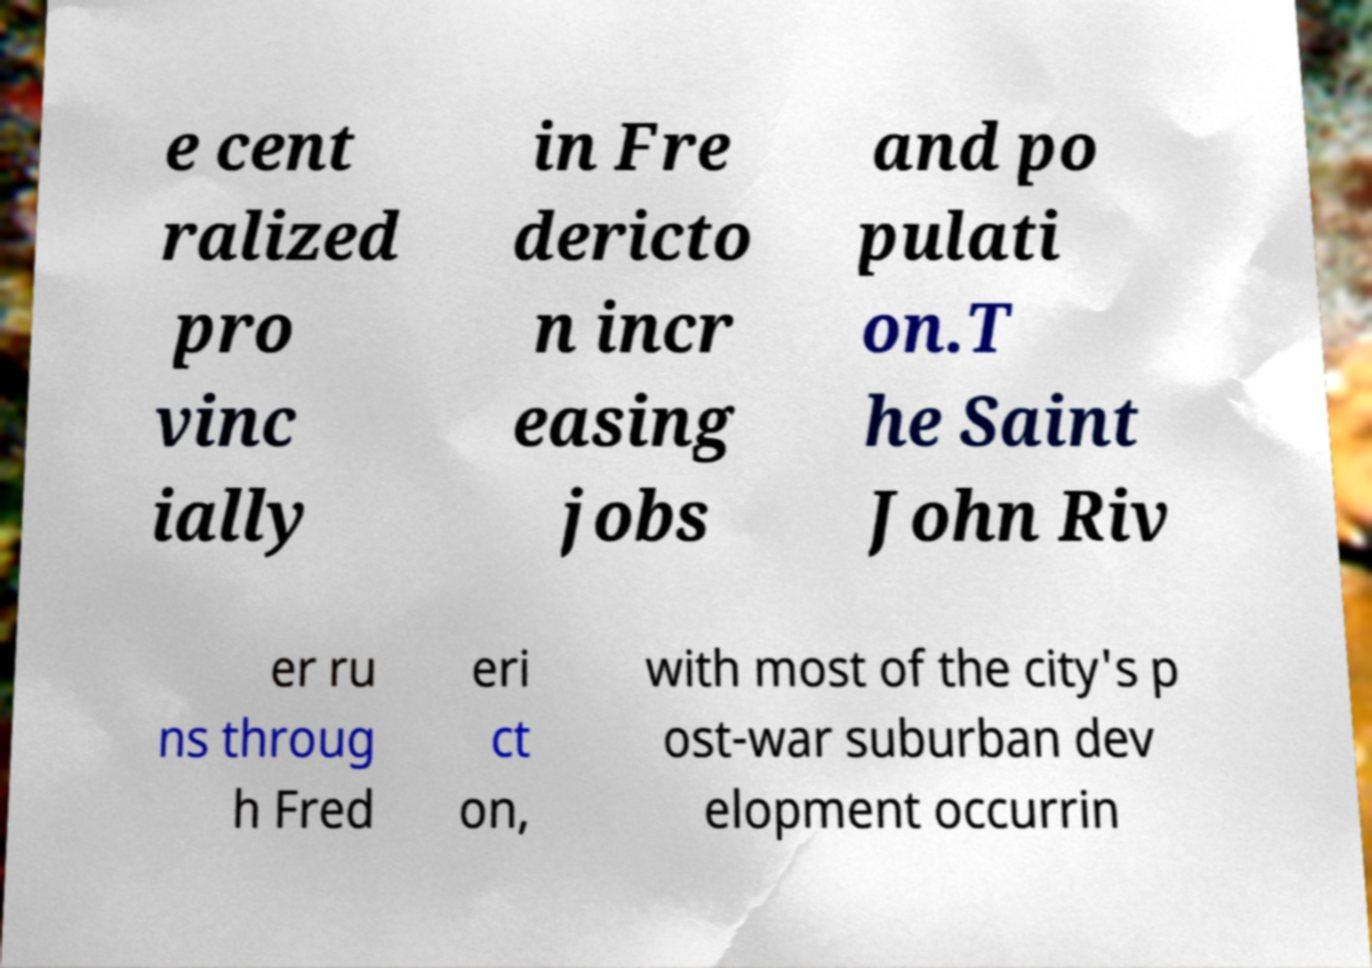Can you read and provide the text displayed in the image?This photo seems to have some interesting text. Can you extract and type it out for me? e cent ralized pro vinc ially in Fre dericto n incr easing jobs and po pulati on.T he Saint John Riv er ru ns throug h Fred eri ct on, with most of the city's p ost-war suburban dev elopment occurrin 